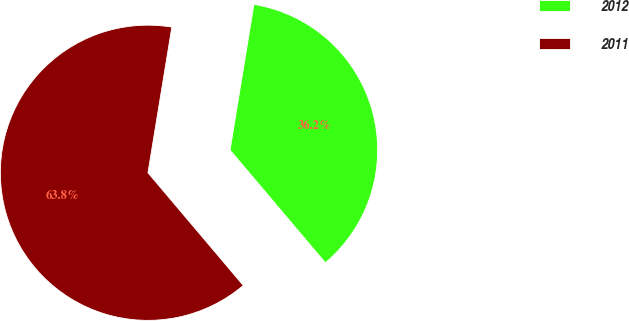Convert chart to OTSL. <chart><loc_0><loc_0><loc_500><loc_500><pie_chart><fcel>2012<fcel>2011<nl><fcel>36.24%<fcel>63.76%<nl></chart> 